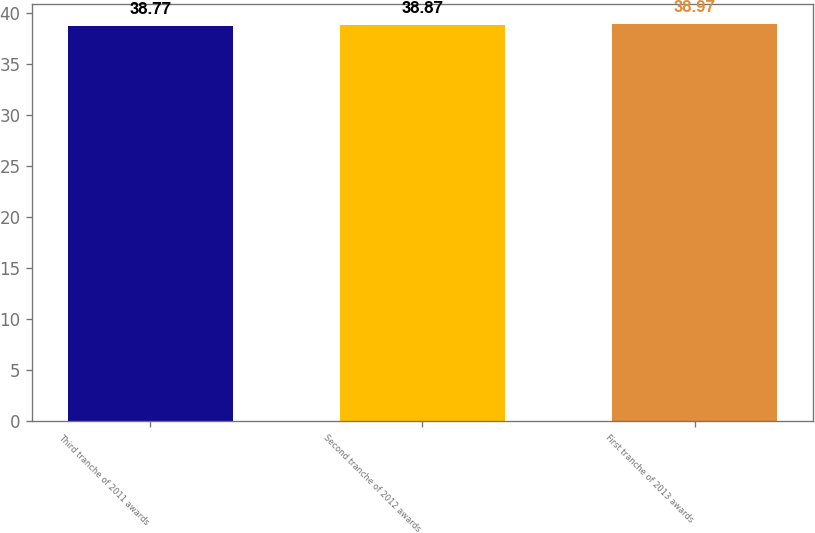Convert chart to OTSL. <chart><loc_0><loc_0><loc_500><loc_500><bar_chart><fcel>Third tranche of 2011 awards<fcel>Second tranche of 2012 awards<fcel>First tranche of 2013 awards<nl><fcel>38.77<fcel>38.87<fcel>38.97<nl></chart> 